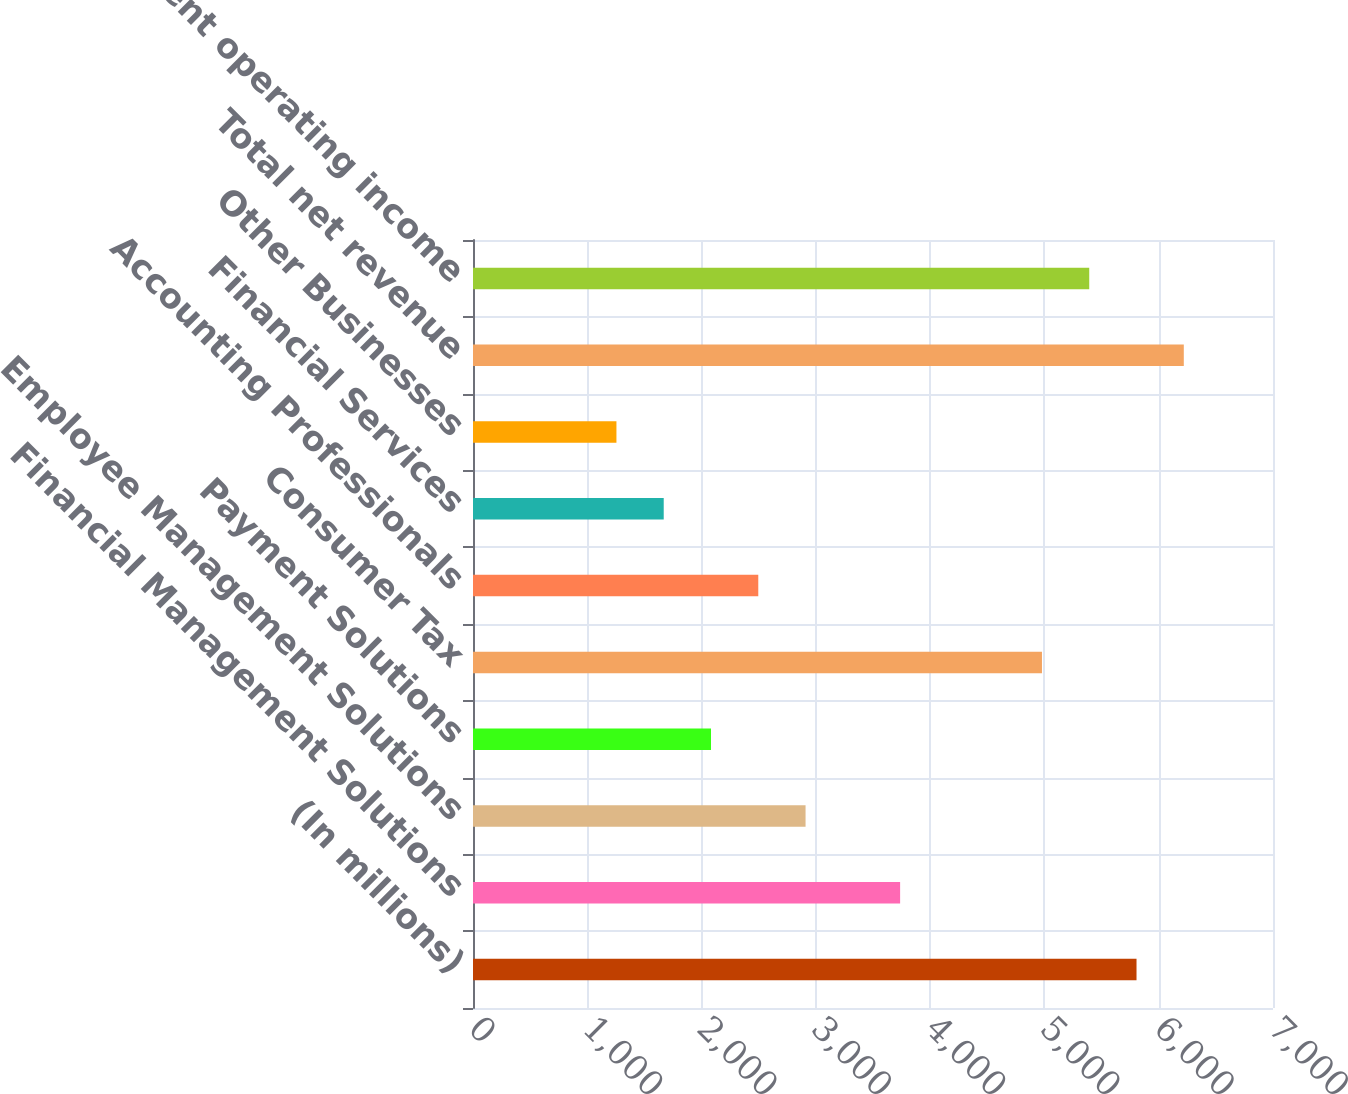Convert chart. <chart><loc_0><loc_0><loc_500><loc_500><bar_chart><fcel>(In millions)<fcel>Financial Management Solutions<fcel>Employee Management Solutions<fcel>Payment Solutions<fcel>Consumer Tax<fcel>Accounting Professionals<fcel>Financial Services<fcel>Other Businesses<fcel>Total net revenue<fcel>Total segment operating income<nl><fcel>5805.8<fcel>3737.3<fcel>2909.9<fcel>2082.5<fcel>4978.4<fcel>2496.2<fcel>1668.8<fcel>1255.1<fcel>6219.5<fcel>5392.1<nl></chart> 